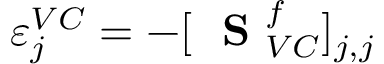Convert formula to latex. <formula><loc_0><loc_0><loc_500><loc_500>\varepsilon _ { j } ^ { V C } = - [ S _ { V C } ^ { f } ] _ { j , j }</formula> 